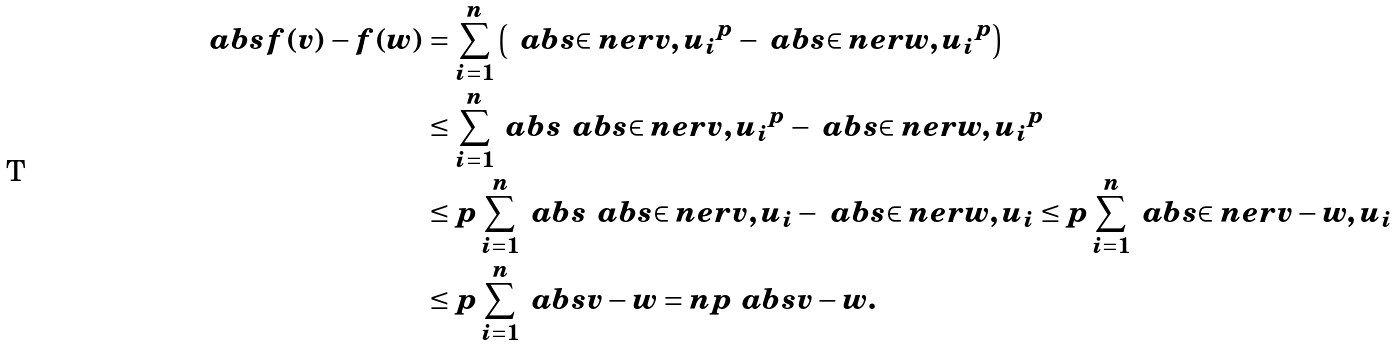<formula> <loc_0><loc_0><loc_500><loc_500>\ a b s { f ( v ) - f ( w ) } & = \sum _ { i = 1 } ^ { n } \left ( \, \ a b s { \in n e r { v , u _ { i } } } ^ { p } - \ a b s { \in n e r { w , u _ { i } } } ^ { p } \right ) \\ & \leq \sum _ { i = 1 } ^ { n } \ a b s { \, \ a b s { \in n e r { v , u _ { i } } } ^ { p } - \ a b s { \in n e r { w , u _ { i } } } ^ { p } } \\ & \leq p \sum _ { i = 1 } ^ { n } \ a b s { \, \ a b s { \in n e r { v , u _ { i } } } - \ a b s { \in n e r { w , u _ { i } } } } \leq p \sum _ { i = 1 } ^ { n } \ a b s { \in n e r { v - w , u _ { i } } } \\ & \leq p \sum _ { i = 1 } ^ { n } \ a b s { v - w } = n p \ a b s { v - w } .</formula> 